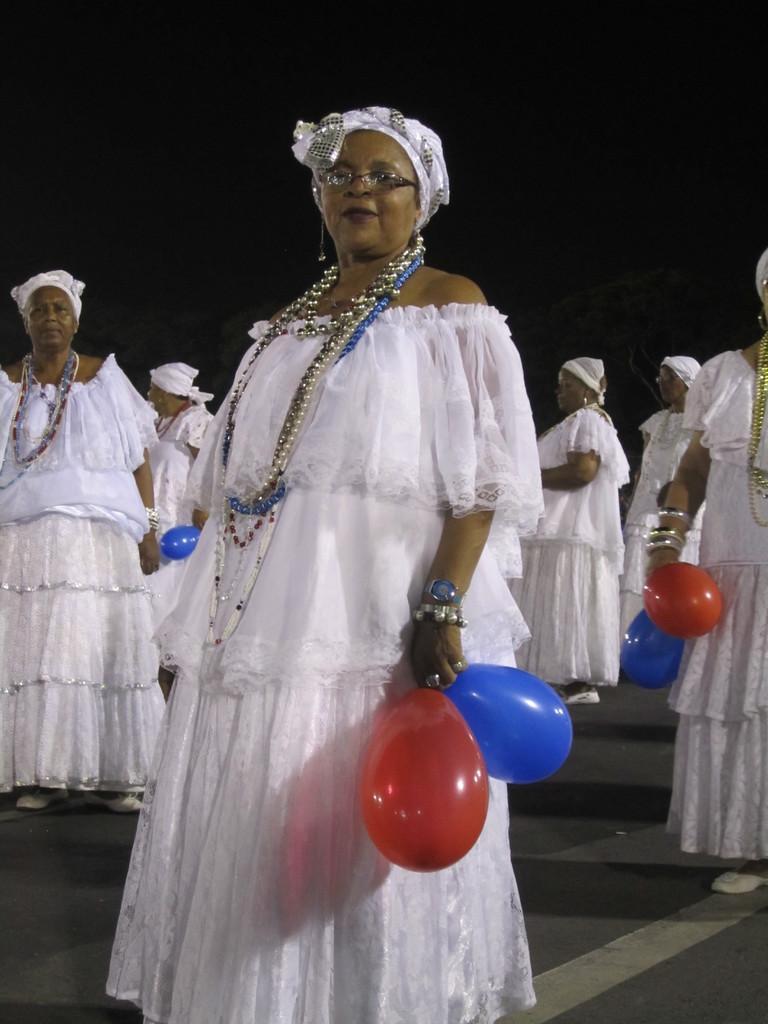Could you give a brief overview of what you see in this image? In the picture we can see a woman standing and she is with white dress and some necklace and she is holding two balloons which are red and blue in color and behind her we can see some women are standing with white dress. 